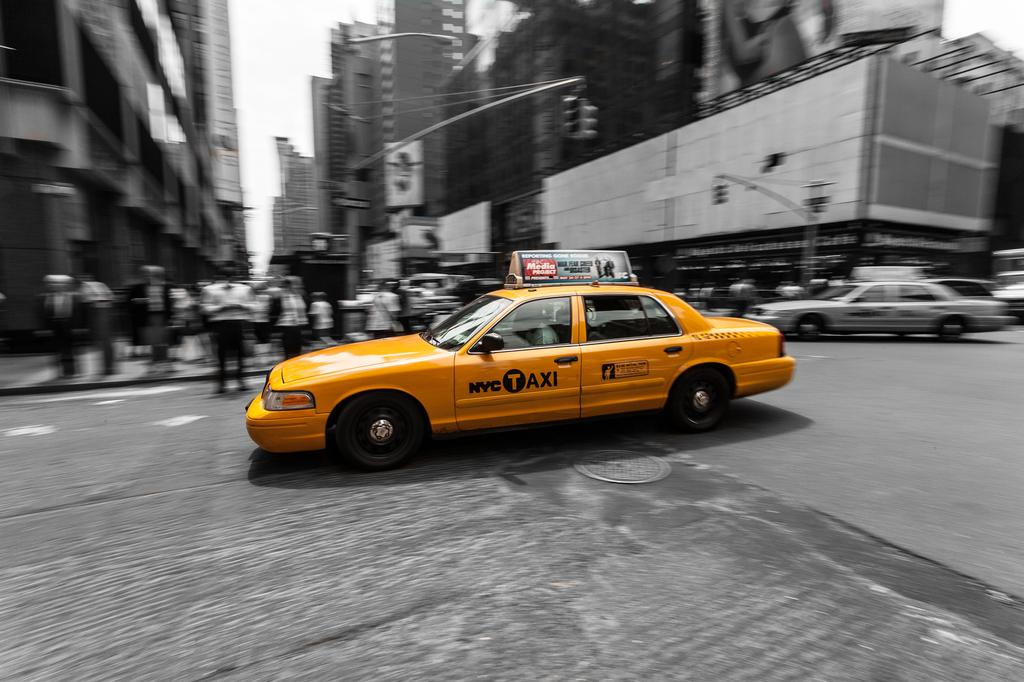<image>
Share a concise interpretation of the image provided. A yellow car that says NYC Taxi is driving through an intersection. 